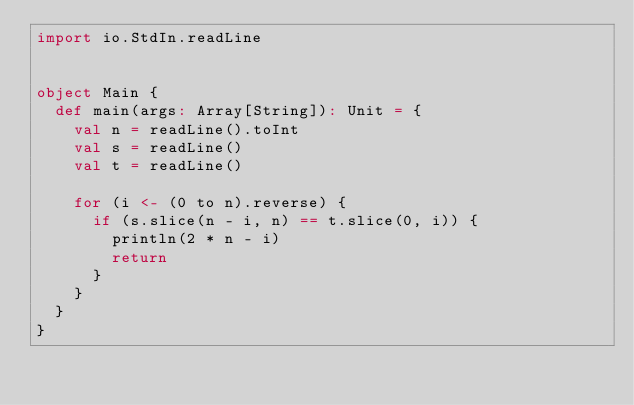<code> <loc_0><loc_0><loc_500><loc_500><_Scala_>import io.StdIn.readLine


object Main {
  def main(args: Array[String]): Unit = {
    val n = readLine().toInt
    val s = readLine()
    val t = readLine()

    for (i <- (0 to n).reverse) {
      if (s.slice(n - i, n) == t.slice(0, i)) {
        println(2 * n - i)
        return
      }
    }
  }
}
</code> 